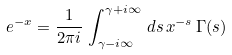Convert formula to latex. <formula><loc_0><loc_0><loc_500><loc_500>e ^ { - x } = \frac { 1 } { 2 \pi i } \, \int _ { \gamma - i \infty } ^ { \gamma + i \infty } \, d s \, x ^ { - s } \, \Gamma ( s )</formula> 